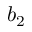<formula> <loc_0><loc_0><loc_500><loc_500>b _ { 2 }</formula> 